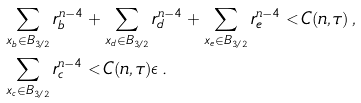<formula> <loc_0><loc_0><loc_500><loc_500>& \sum _ { x _ { b } \in B _ { 3 / 2 } } r _ { b } ^ { n - 4 } + \sum _ { x _ { d } \in B _ { 3 / 2 } } r _ { d } ^ { n - 4 } + \sum _ { x _ { e } \in B _ { 3 / 2 } } r _ { e } ^ { n - 4 } < C ( n , \tau ) \, , \\ & \sum _ { x _ { c } \in B _ { 3 / 2 } } r _ { c } ^ { n - 4 } < C ( n , \tau ) \epsilon \, .</formula> 